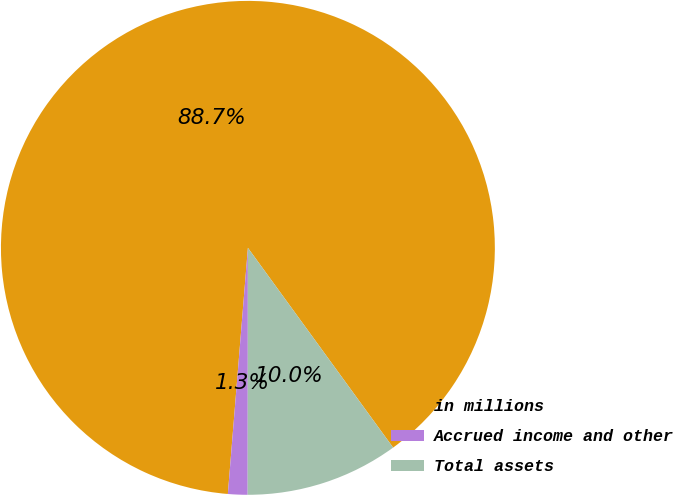<chart> <loc_0><loc_0><loc_500><loc_500><pie_chart><fcel>in millions<fcel>Accrued income and other<fcel>Total assets<nl><fcel>88.7%<fcel>1.28%<fcel>10.02%<nl></chart> 